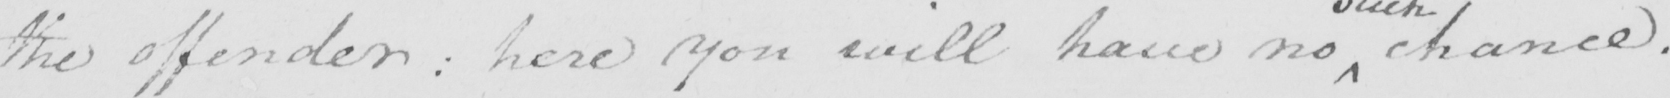Transcribe the text shown in this historical manuscript line. the offender :  here you will have no chance . 